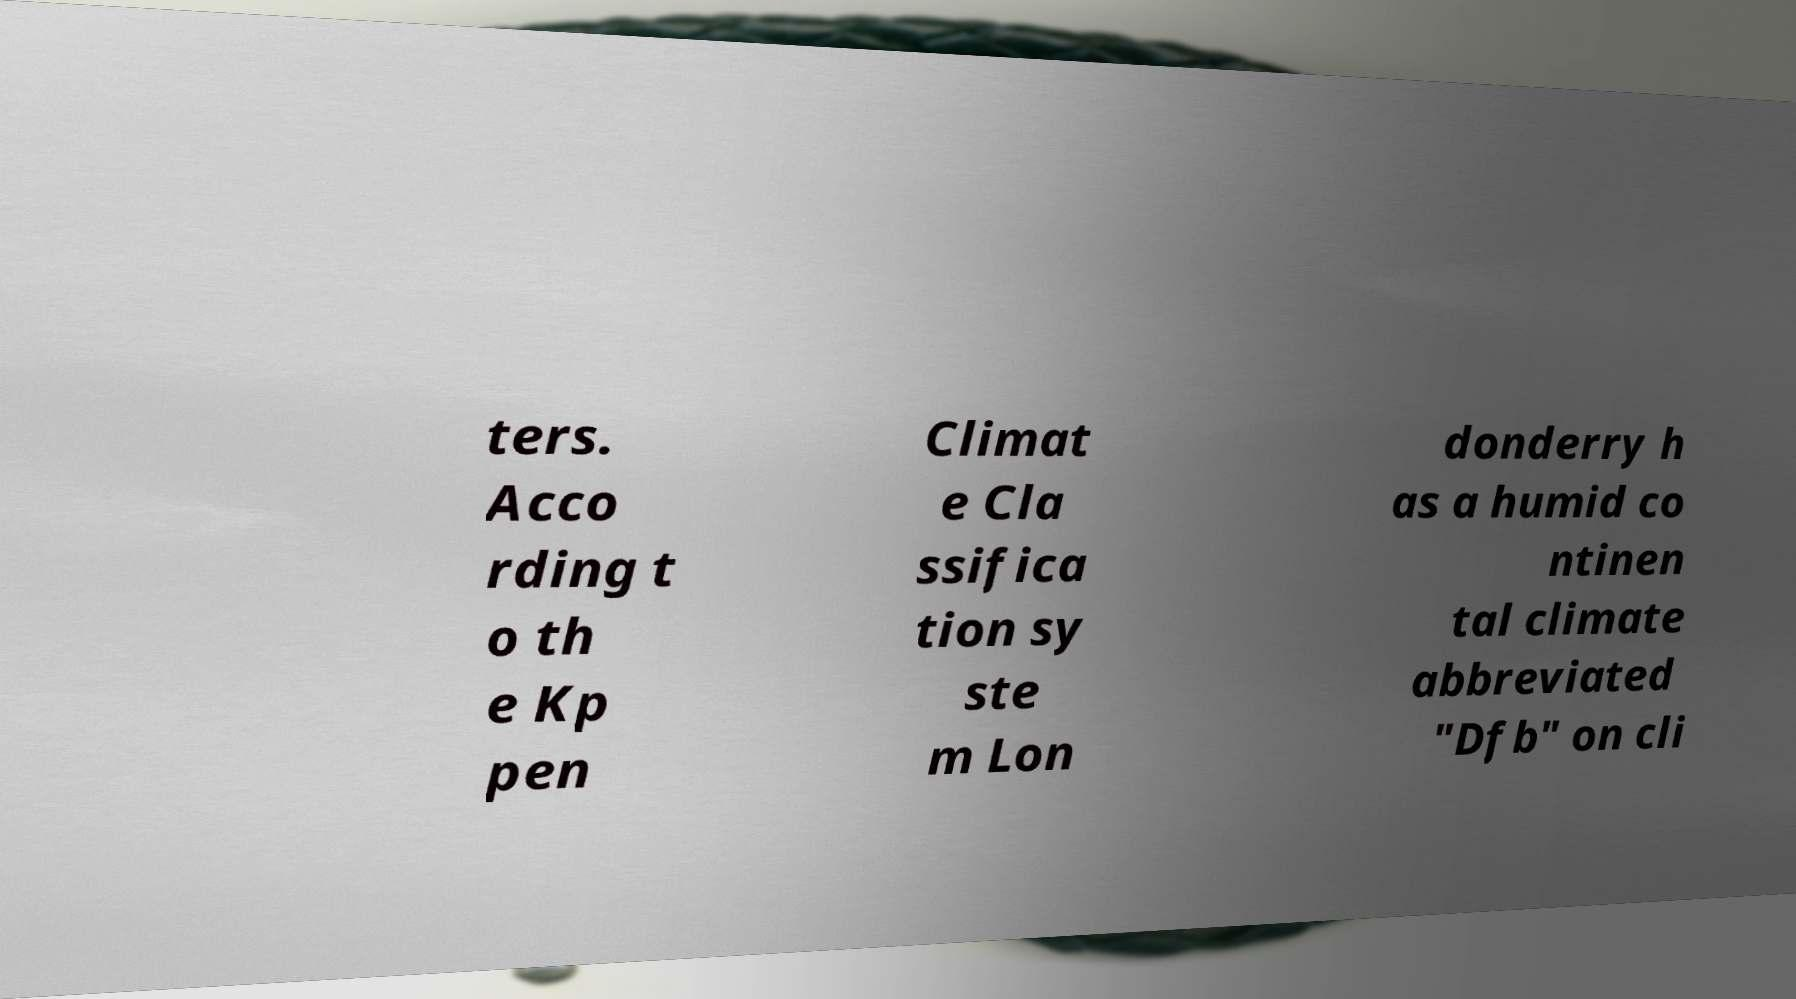Please read and relay the text visible in this image. What does it say? ters. Acco rding t o th e Kp pen Climat e Cla ssifica tion sy ste m Lon donderry h as a humid co ntinen tal climate abbreviated "Dfb" on cli 